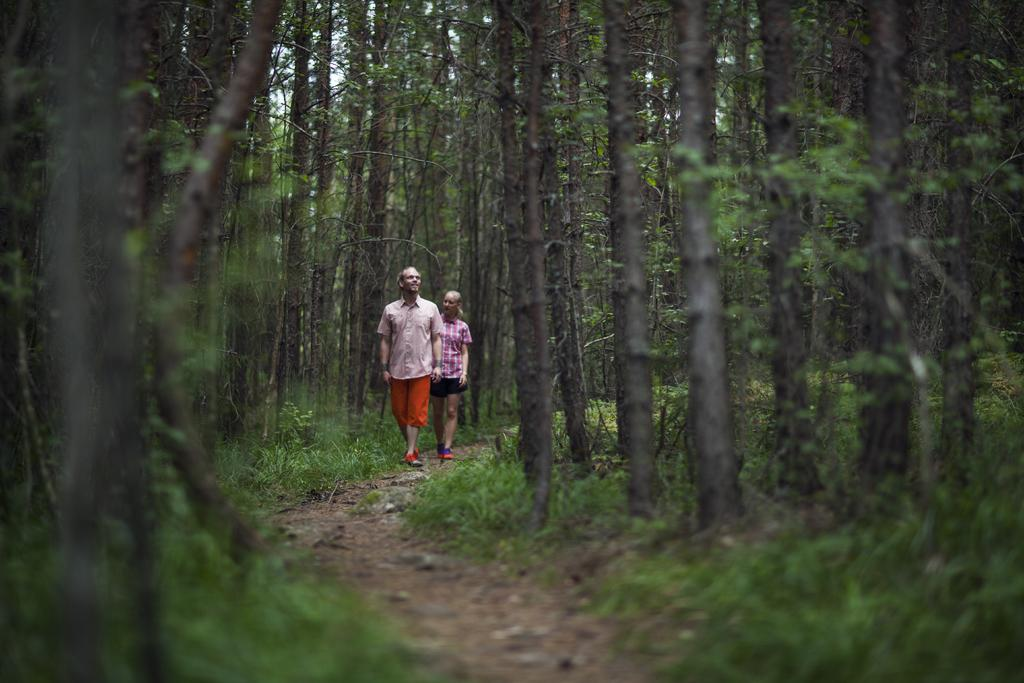What are the two persons in the image doing? The two persons in the image are walking in the center of the image. What can be seen in the background of the image? There are trees in the background of the image. What type of vegetation is visible at the bottom of the image? Grass is visible at the bottom of the image. What is the surface that the grass is growing on? The ground is visible at the bottom of the image. What type of curtain can be seen hanging from the trees in the image? There are no curtains present in the image; it features two persons walking and trees in the background. 